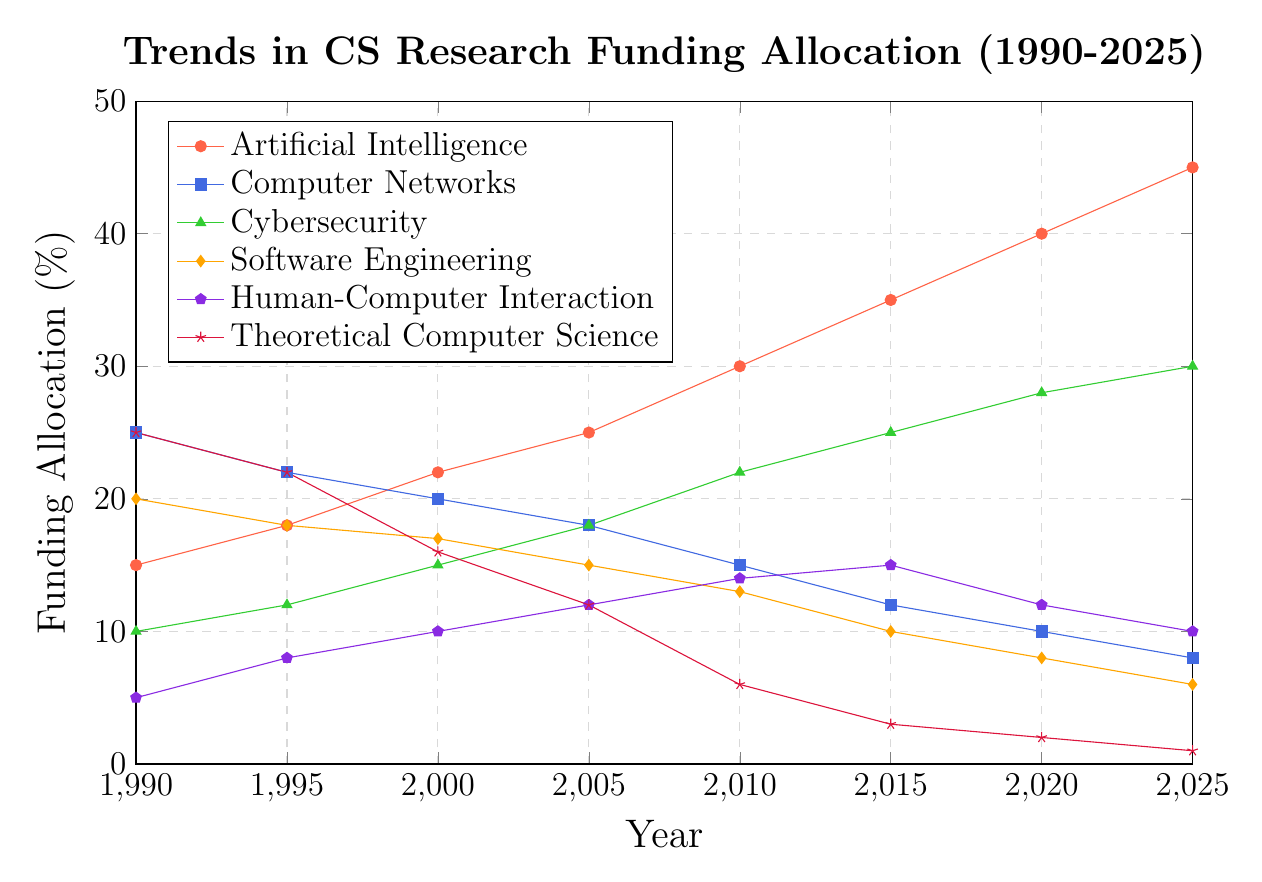what are the trends observed in Artificial Intelligence and Theoretical Computer Science funding allocation from 1990 to 2025? To observe the trends, look at the lines representing Artificial Intelligence (red) and Theoretical Computer Science (crimson) over the given years. The funding for Artificial Intelligence has increased consistently from 15% in 1990 to 45% in 2025. Conversely, Theoretical Computer Science funding has decreased steadily from 25% in 1990 to 1% in 2025.
Answer: Artificial Intelligence: increasing, Theoretical Computer Science: decreasing In which year do Cybersecurity and Software Engineering have the same funding? To find the year with equal funding, locate the intersection of the green (Cybersecurity) and orange (Software Engineering) lines. They intersect at around 2005, where both have a 15% funding allocation.
Answer: 2005 How much more funding does Artificial Intelligence receive compared to Human-Computer Interaction in 2025? Identify the values for Artificial Intelligence (red) and Human-Computer Interaction (purple) in 2025. The funding for Artificial Intelligence is 45%, and for Human-Computer Interaction, it is 10%. The difference is 45% - 10% = 35%.
Answer: 35% What's the average funding allocation for Computer Networks from 1990 to 2025? Calculate the average by summing the values for Computer Networks (blue) across the years: (25 + 22 + 20 + 18 + 15 + 12 + 10 + 8) = 130, and then divide by the number of years (8). 130/8 = 16.25%.
Answer: 16.25% In what range does the funding for Software Engineering lie between 1990 and 2025? Look at the orange line representing Software Engineering. The highest value is 20% in 1990, and the lowest is 6% in 2025. Therefore, the range is 6% to 20%.
Answer: 6% to 20% Which subfield has the most significant decline in funding from 1990 to 2025? Compare the starting and ending values of all subfields. Theoretical Computer Science (crimson) funding decreased from 25% in 1990 to 1% in 2025, which is a decline of 24%. This is the most significant decline.
Answer: Theoretical Computer Science Between 2010 and 2020, which subfield sees the highest increase in its funding allocation? Compare the funding allocation in 2010 and 2020 for all subfields. Cybersecurity (green) went from 22% in 2010 to 28% in 2020, an increase of 6%, which is the highest among all subfields.
Answer: Cybersecurity Which subfield receives the least funding consistently from 1990 to 2025? By visually following the lines, Human-Computer Interaction (purple) can be seen staying consistently low even though there are slight increases and decreases. The look at the values confirms this, with it starting at 5% and ending at 10%.
Answer: Human-Computer Interaction What is the total funding allocation for Cybersecurity and Human-Computer Interaction in 2020? Add the funding percentages for Cybersecurity (green) and Human-Computer Interaction (purple) in 2020. Cybersecurity is at 28% and Human-Computer Interaction is at 12%. The total is 28% + 12% = 40%.
Answer: 40% In which year does Software Engineering funding fall below 10% for the first time? Track the orange line for Software Engineering and find the year it first dips below 10%. The funding is 10% in 2015 and drops to 8% in 2020. The first time it falls below 10% is in 2020.
Answer: 2020 